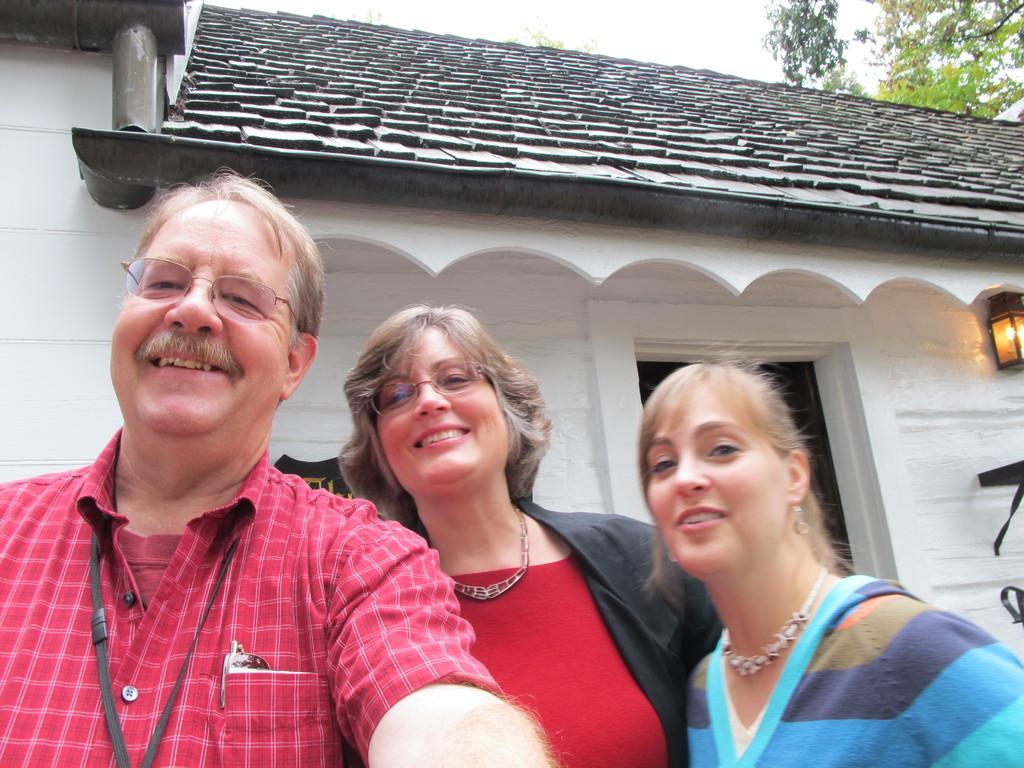Could you give a brief overview of what you see in this image? The picture is clicked near a house. In the foreground of the picture there are two women and a man smiling, behind them there is a door and a name board. At the top there are trees. On the right there is a lamp. 